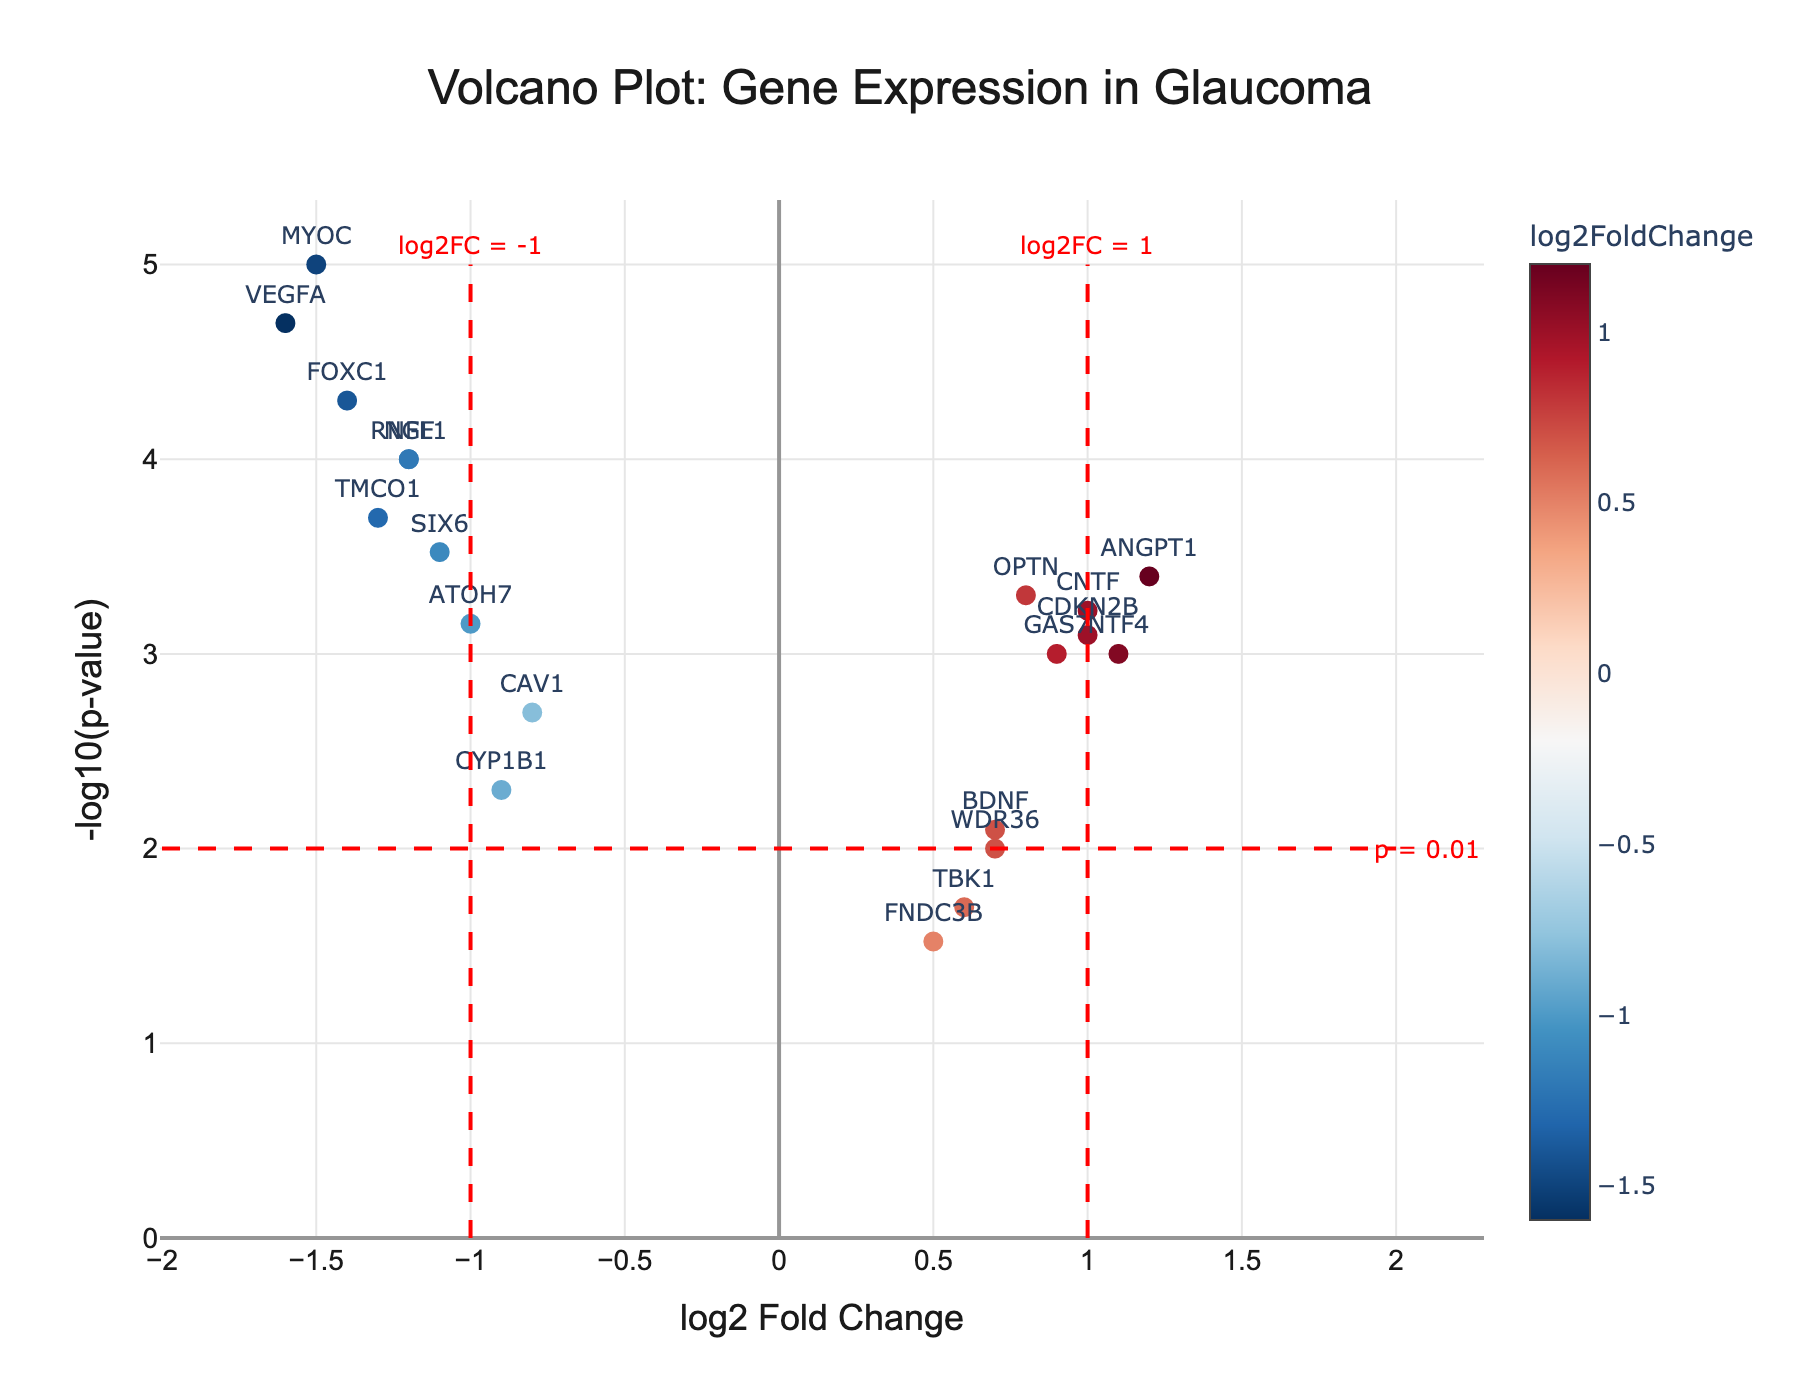What is the title of the volcano plot? The title is located at the top of the plot and provides the main context or purpose of the visualization, which in this case is "Volcano Plot: Gene Expression in Glaucoma".
Answer: Volcano Plot: Gene Expression in Glaucoma What do the x-axis and y-axis represent? The x-axis represents the "log2 Fold Change", which indicates how much a gene’s expression level changes between glaucoma and non-glaucomatous individuals. The y-axis represents "-log10(p-value)", which reflects the statistical significance of the genes.
Answer: The x-axis shows log2 Fold Change, and the y-axis shows -log10(p-value) How many genes have a log2 Fold Change greater than 1 or less than -1? To find this, count the number of points to the right of the line x = 1 and to the left of the line x = -1. There are 4 points on the right and 8 on the left.
Answer: 12 Which gene has the highest log2 Fold Change and what is its value? The highest log2 Fold Change is determined by looking at the point farthest to the right along the x-axis. The gene is ANGPT1 with a value of 1.2.
Answer: ANGPT1, 1.2 What are the threshold lines present in the plot and what do they represent? The plot includes three threshold lines: two vertical lines at x = -1 and x = 1 (log2 Fold Change thresholds) and one horizontal line at y = 2 (-log10(p-value) threshold corresponding to p = 0.01). These lines help identify significantly different expressed genes.
Answer: Vertical lines at log2FC = -1 and 1, and horizontal line at p = 0.01 How many genes are significant with both log2 Fold Change greater than 1 or less than -1 and p-value < 0.01? To determine this, count the number of markers outside the vertical lines at x = -1 and 1 and above the horizontal line at y = 2. There are 8 such genes.
Answer: 8 Which gene has the smallest p-value and what is the corresponding -log10(p-value) value? The smallest p-value will correspond to the highest point on the y-axis. The gene is MYOC with a -log10(p-value) of -log10(0.00001) = 5.
Answer: MYOC, 5 What is the range of log2 Fold Change values observed in the plot? The range is determined by finding the minimum and maximum values on the x-axis. The minimum log2 Fold Change is -1.6 for VEGFA, and the maximum is 1.2 for ANGPT1.
Answer: -1.6 to 1.2 Compare the log2 Fold Change values of RNFL1 and CNTF; which is higher? Look at the x-axis positions of RNFL1 and CNTF. RNFL1 has a value of -1.2 and CNTF has a value of 1.0, so CNTF's log2 Fold Change is higher.
Answer: CNTF What do the colors of the markers represent? The colors represent the log2 Fold Change values, with a color scale from a certain range. The color changes based on the value, which is visually supported by the color bar legend on the right side of the plot.
Answer: log2 Fold Change values 